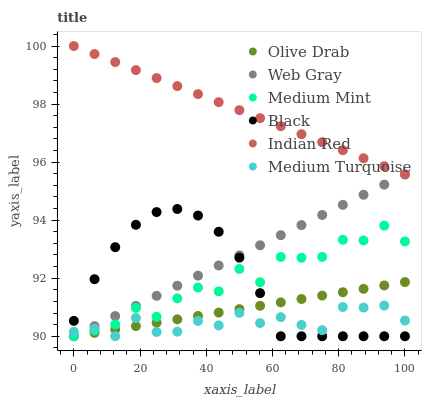Does Medium Turquoise have the minimum area under the curve?
Answer yes or no. Yes. Does Indian Red have the maximum area under the curve?
Answer yes or no. Yes. Does Web Gray have the minimum area under the curve?
Answer yes or no. No. Does Web Gray have the maximum area under the curve?
Answer yes or no. No. Is Indian Red the smoothest?
Answer yes or no. Yes. Is Medium Mint the roughest?
Answer yes or no. Yes. Is Web Gray the smoothest?
Answer yes or no. No. Is Web Gray the roughest?
Answer yes or no. No. Does Medium Mint have the lowest value?
Answer yes or no. Yes. Does Indian Red have the lowest value?
Answer yes or no. No. Does Indian Red have the highest value?
Answer yes or no. Yes. Does Web Gray have the highest value?
Answer yes or no. No. Is Web Gray less than Indian Red?
Answer yes or no. Yes. Is Indian Red greater than Medium Turquoise?
Answer yes or no. Yes. Does Olive Drab intersect Web Gray?
Answer yes or no. Yes. Is Olive Drab less than Web Gray?
Answer yes or no. No. Is Olive Drab greater than Web Gray?
Answer yes or no. No. Does Web Gray intersect Indian Red?
Answer yes or no. No. 